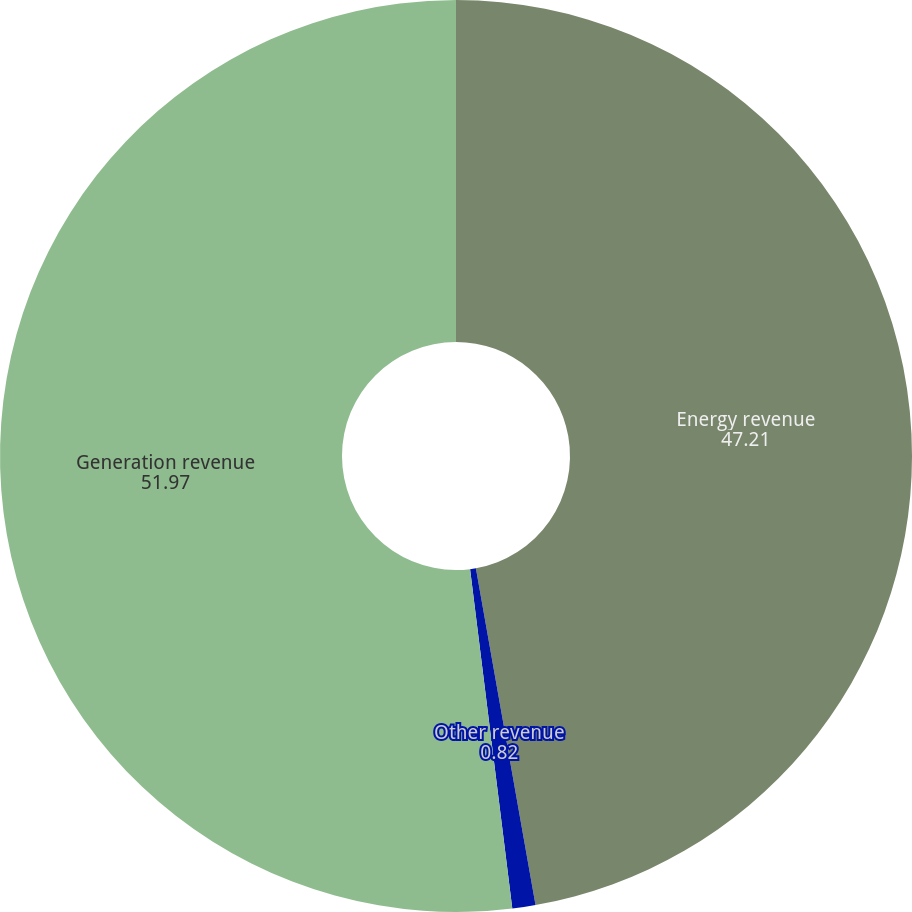Convert chart to OTSL. <chart><loc_0><loc_0><loc_500><loc_500><pie_chart><fcel>Energy revenue<fcel>Other revenue<fcel>Generation revenue<nl><fcel>47.21%<fcel>0.82%<fcel>51.97%<nl></chart> 